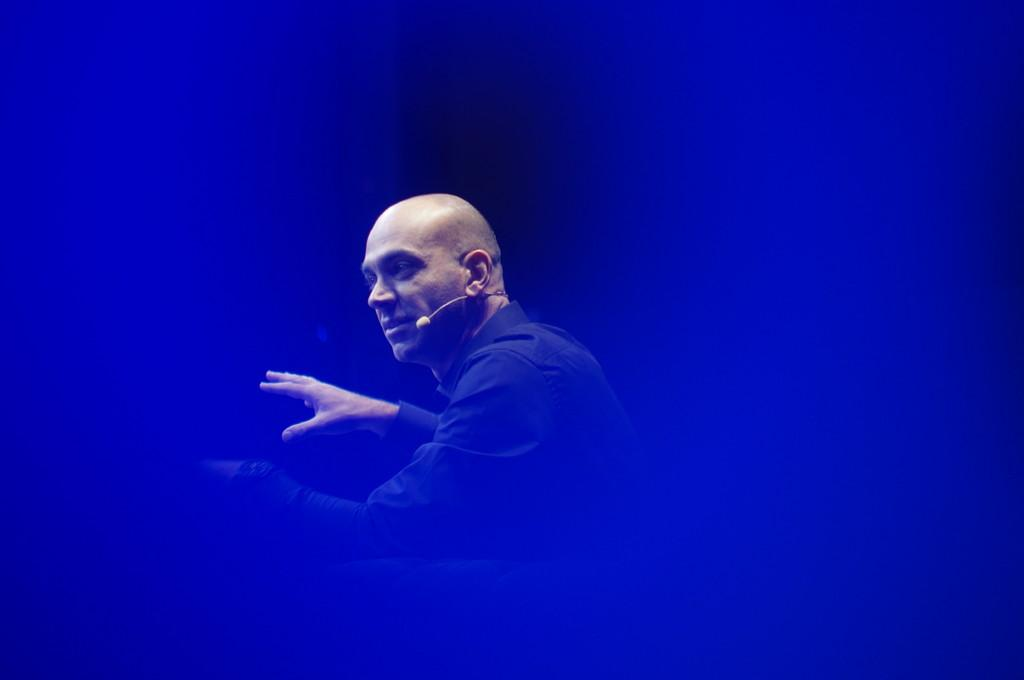Who or what is the main subject of the image? There is a person in the image. In which direction is the person facing? The person is facing towards the left. What is the person wearing in the image? The person is wearing a microphone (mike). Can you describe the background of the image? The background of the image is blurred. What type of oil can be seen dripping from the carriage in the image? There is no carriage or oil present in the image. What cast member from the movie is visible in the image? The image does not depict any cast members from a movie. 